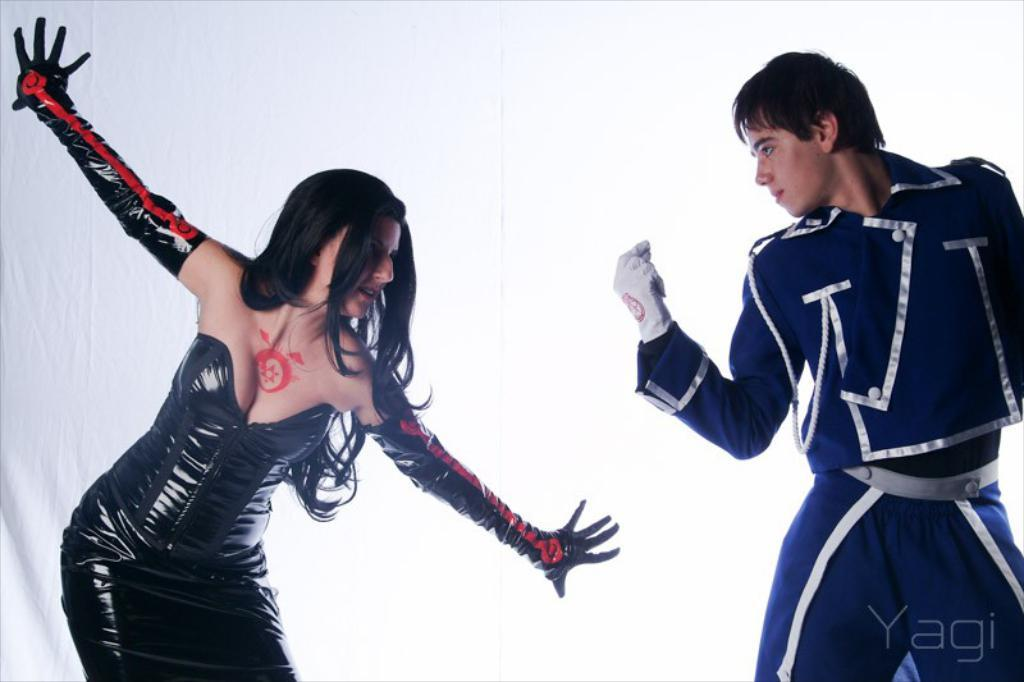How many people are in the image? There are two people in the image, a woman and a man. What can be seen in the background of the image? There is a curtain in the background of the image. What type of glue is being used by the woman in the image? There is no glue present in the image, and the woman is not using any glue. What offer is being made by the man in the image? There is no offer being made by the man in the image; he is simply present in the image with the woman. 